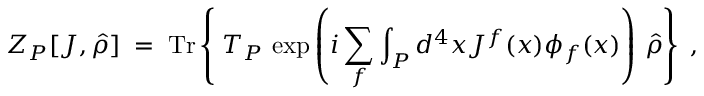Convert formula to latex. <formula><loc_0><loc_0><loc_500><loc_500>Z _ { P } [ J , \hat { \rho } ] \, = \, T r \left \{ { } T _ { P } \, \exp \left ( i \sum _ { f } \int _ { P } d ^ { 4 } x J ^ { f } ( x ) \phi _ { f } ( x ) \right ) \, \hat { \rho } \right \} \, ,</formula> 